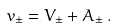<formula> <loc_0><loc_0><loc_500><loc_500>v _ { \pm } = V _ { \pm } + A _ { \pm } \, .</formula> 